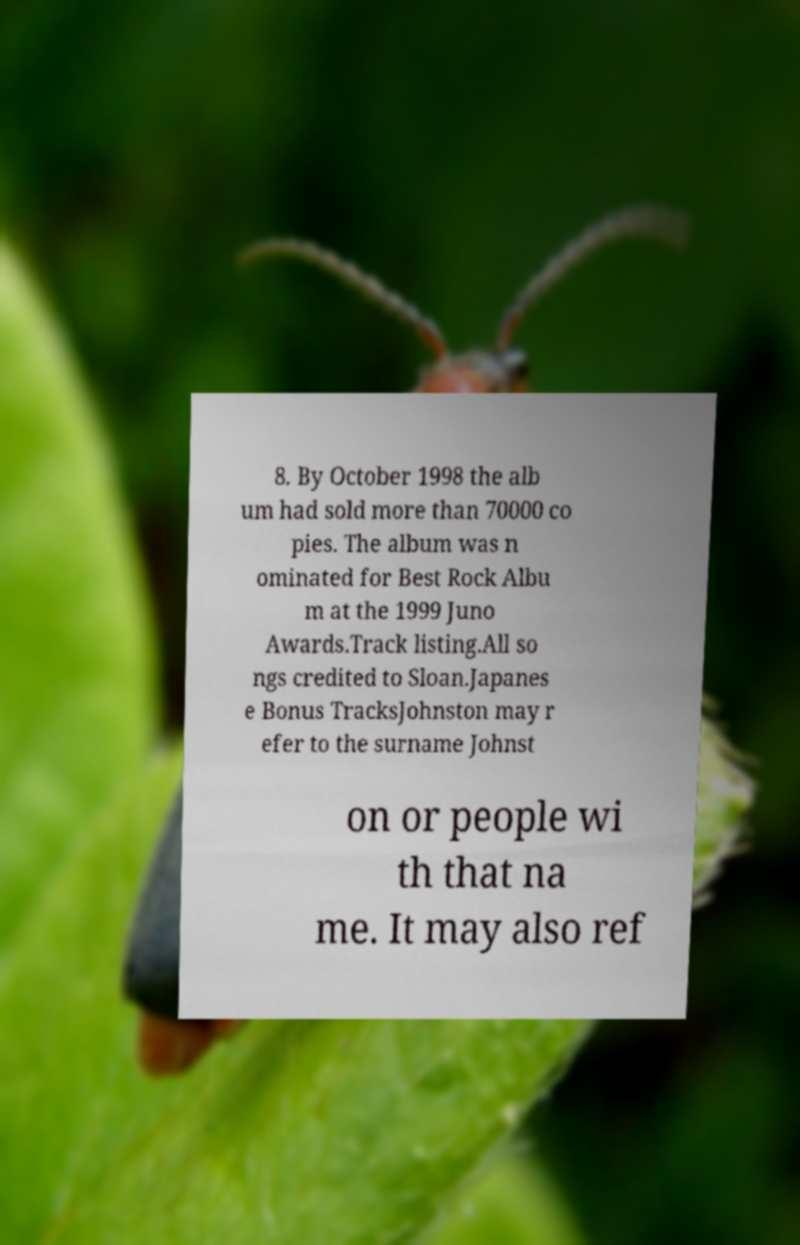Can you accurately transcribe the text from the provided image for me? 8. By October 1998 the alb um had sold more than 70000 co pies. The album was n ominated for Best Rock Albu m at the 1999 Juno Awards.Track listing.All so ngs credited to Sloan.Japanes e Bonus TracksJohnston may r efer to the surname Johnst on or people wi th that na me. It may also ref 